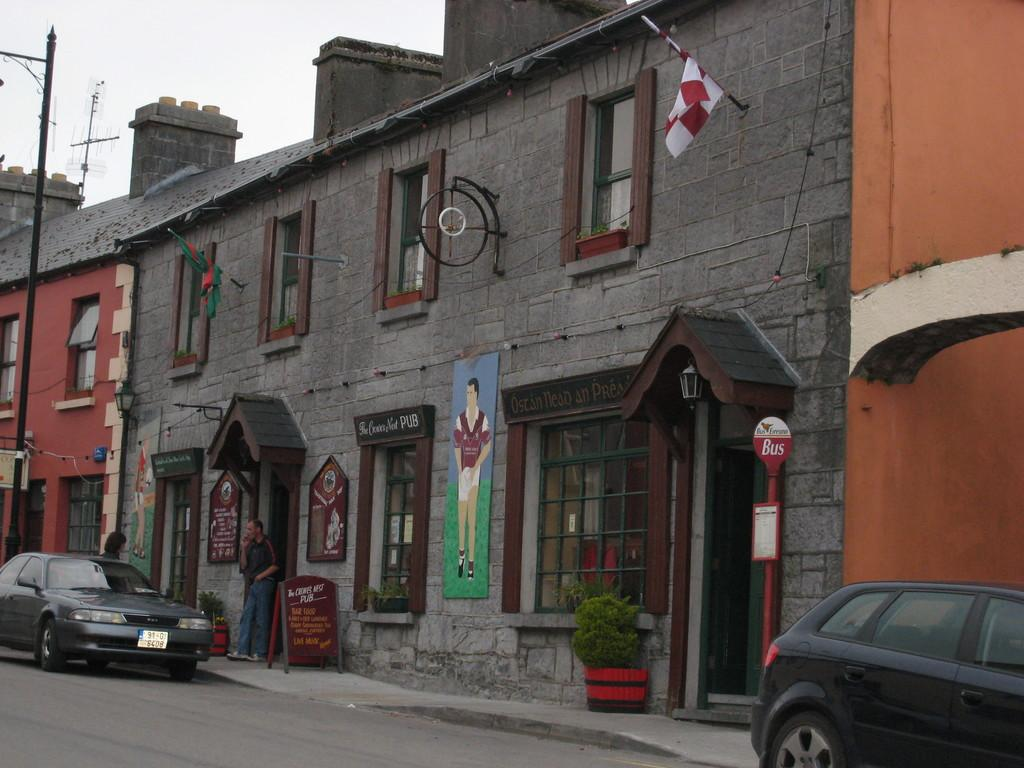What can be seen on the road in the image? There are vehicles on the road in the image. What type of natural elements are present in the image? There are plants in the image. What structures can be seen in the image? There are boards, poles, and houses in the image. What additional items are present in the image? There are flags in the image. How many people are in the image? There are two persons in the image. What is visible in the background of the image? The sky is visible in the background of the image. What type of scent can be detected from the rail in the image? There is no rail present in the image, so it is not possible to detect any scent from it. 